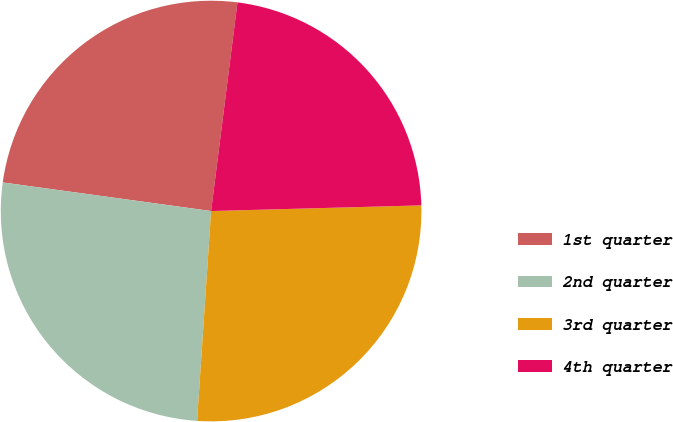Convert chart. <chart><loc_0><loc_0><loc_500><loc_500><pie_chart><fcel>1st quarter<fcel>2nd quarter<fcel>3rd quarter<fcel>4th quarter<nl><fcel>24.83%<fcel>26.11%<fcel>26.49%<fcel>22.57%<nl></chart> 